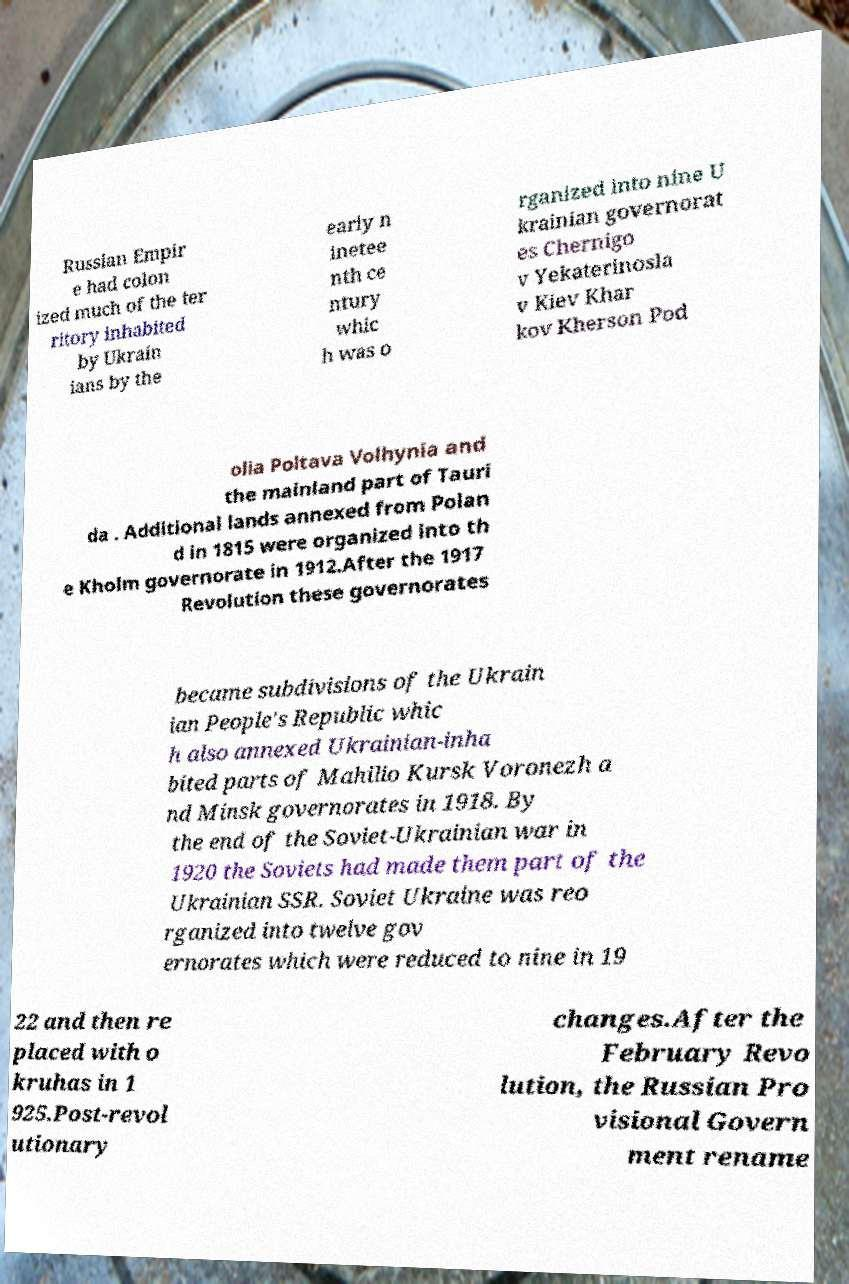What messages or text are displayed in this image? I need them in a readable, typed format. Russian Empir e had colon ized much of the ter ritory inhabited by Ukrain ians by the early n inetee nth ce ntury whic h was o rganized into nine U krainian governorat es Chernigo v Yekaterinosla v Kiev Khar kov Kherson Pod olia Poltava Volhynia and the mainland part of Tauri da . Additional lands annexed from Polan d in 1815 were organized into th e Kholm governorate in 1912.After the 1917 Revolution these governorates became subdivisions of the Ukrain ian People's Republic whic h also annexed Ukrainian-inha bited parts of Mahilio Kursk Voronezh a nd Minsk governorates in 1918. By the end of the Soviet-Ukrainian war in 1920 the Soviets had made them part of the Ukrainian SSR. Soviet Ukraine was reo rganized into twelve gov ernorates which were reduced to nine in 19 22 and then re placed with o kruhas in 1 925.Post-revol utionary changes.After the February Revo lution, the Russian Pro visional Govern ment rename 